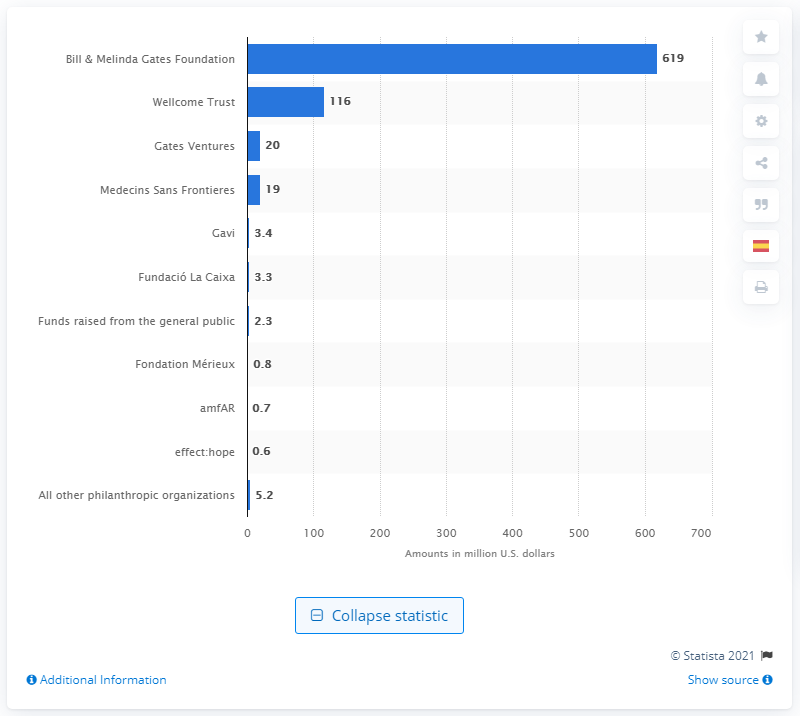Specify some key components in this picture. In 2019, the Bill & Melinda Gates Foundation raised a total of 619 million US dollars. 